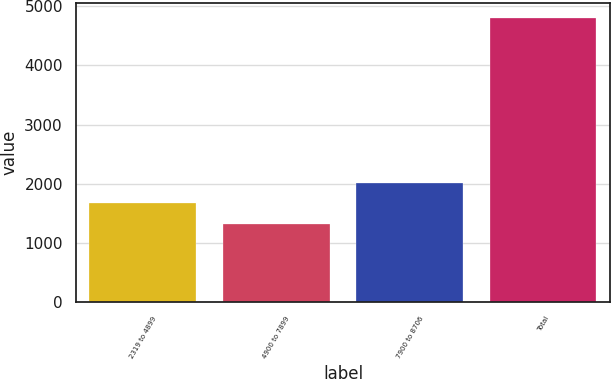Convert chart to OTSL. <chart><loc_0><loc_0><loc_500><loc_500><bar_chart><fcel>2319 to 4899<fcel>4900 to 7899<fcel>7900 to 8706<fcel>Total<nl><fcel>1673.4<fcel>1325<fcel>2021.8<fcel>4809<nl></chart> 